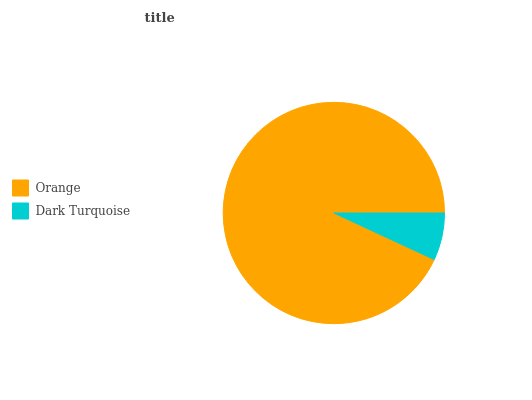Is Dark Turquoise the minimum?
Answer yes or no. Yes. Is Orange the maximum?
Answer yes or no. Yes. Is Dark Turquoise the maximum?
Answer yes or no. No. Is Orange greater than Dark Turquoise?
Answer yes or no. Yes. Is Dark Turquoise less than Orange?
Answer yes or no. Yes. Is Dark Turquoise greater than Orange?
Answer yes or no. No. Is Orange less than Dark Turquoise?
Answer yes or no. No. Is Orange the high median?
Answer yes or no. Yes. Is Dark Turquoise the low median?
Answer yes or no. Yes. Is Dark Turquoise the high median?
Answer yes or no. No. Is Orange the low median?
Answer yes or no. No. 